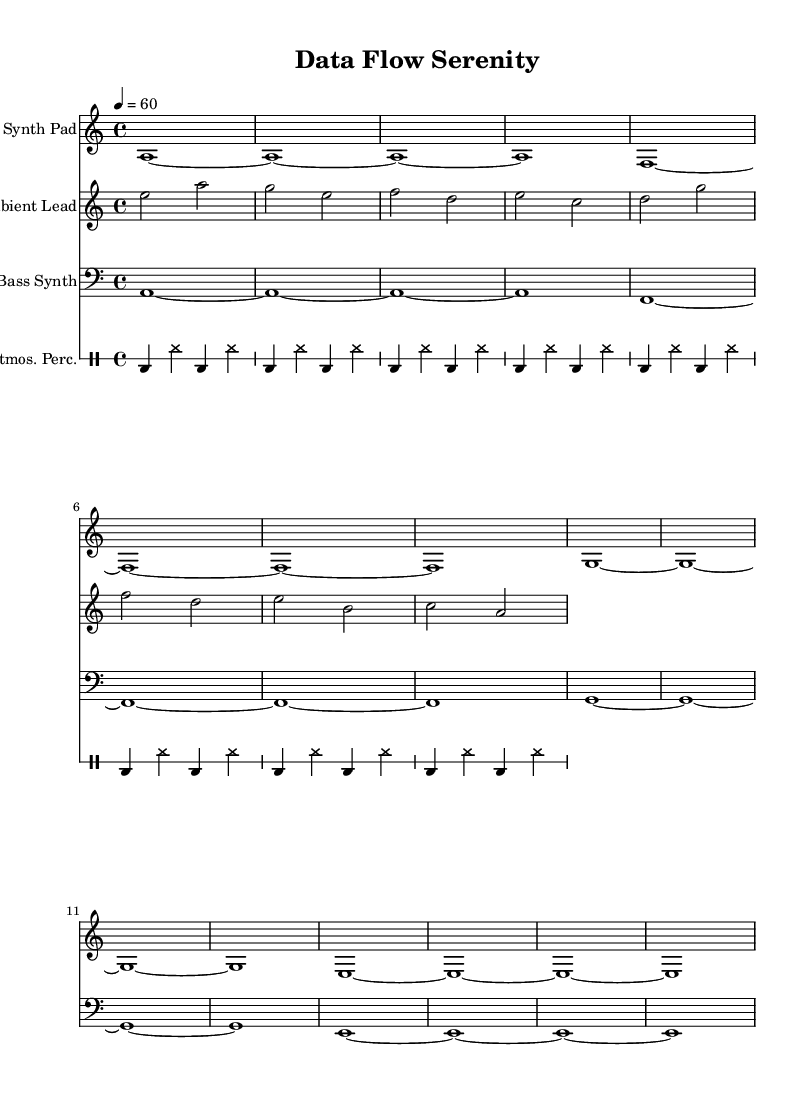What is the key signature of this music? The key signature is indicated by the notes, which are predominantly based around A minor, characterized by the presence of A, C, and E notes.
Answer: A minor What is the time signature of this music? The time signature is expressed at the beginning of the sheet music, noted as 4/4, indicating four beats per measure.
Answer: 4/4 What is the tempo of this piece? The tempo marking at the start states "4 = 60," which means there are 60 beats per minute, indicating a moderate pace.
Answer: 60 How many staffs are present in this score? The score displays four distinct staffs: one each for the synth pad, ambient lead, bass synth, and atmospheric percussion.
Answer: Four What type of melody do the "Ambient Lead" instruments use? The "Ambient Lead" section utilizes a flowing melodic line which includes patterns that ascend and descend, common in ambient music.
Answer: Flowing What is the primary instrument used for the bass line in this score? The bass line is played by the "Bass Synth" instrument, which is specifically noted in its own staff and contributes to the low frequencies typical in electronic music.
Answer: Bass Synth How is the percussive element represented in this piece? The percussive element is indicated by the "Atmos. Perc." staff, showing a simple repeated rhythm with bass drums and hi-hats, typical in ambient electronic compositions.
Answer: Repeated rhythm 